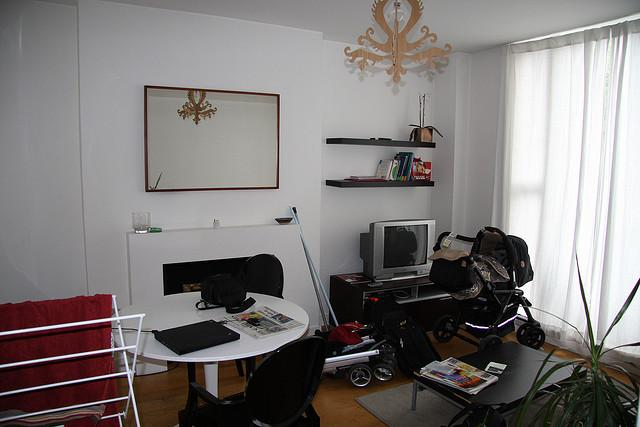Which object in the room is the most mobile? stroller 